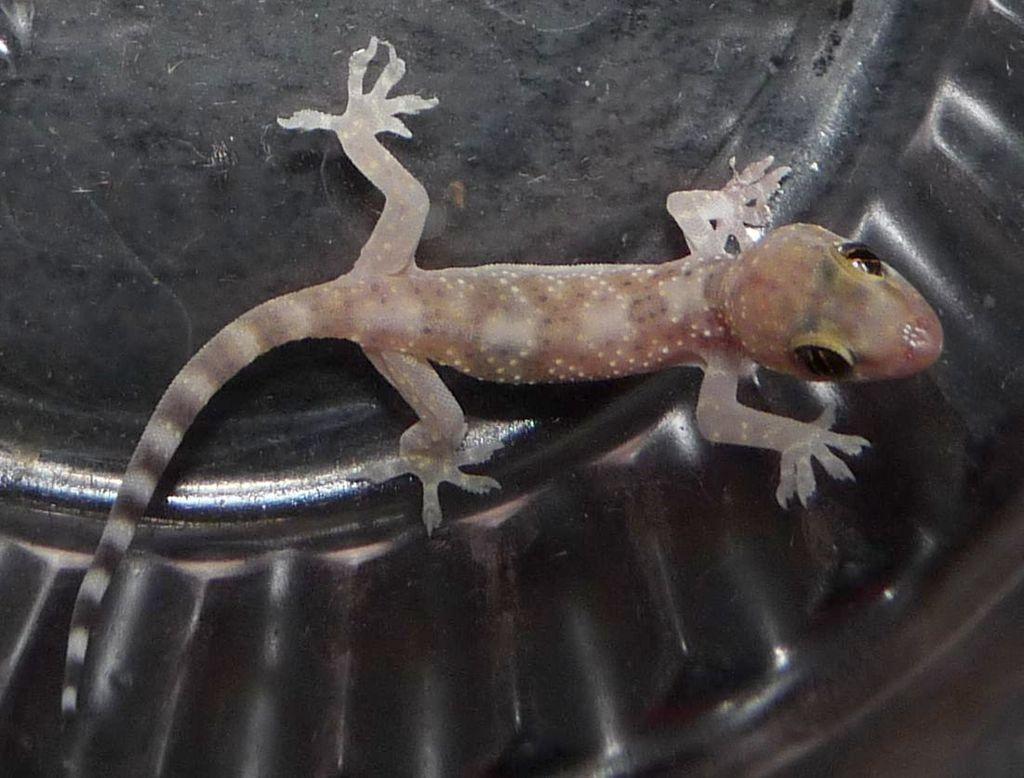How would you summarize this image in a sentence or two? There is a lizard on an object. 